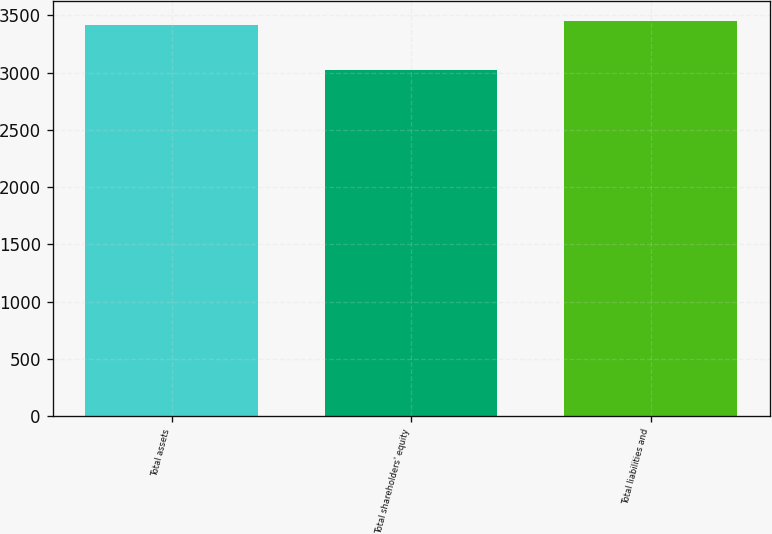Convert chart. <chart><loc_0><loc_0><loc_500><loc_500><bar_chart><fcel>Total assets<fcel>Total shareholders' equity<fcel>Total liabilities and<nl><fcel>3414<fcel>3026<fcel>3452.8<nl></chart> 